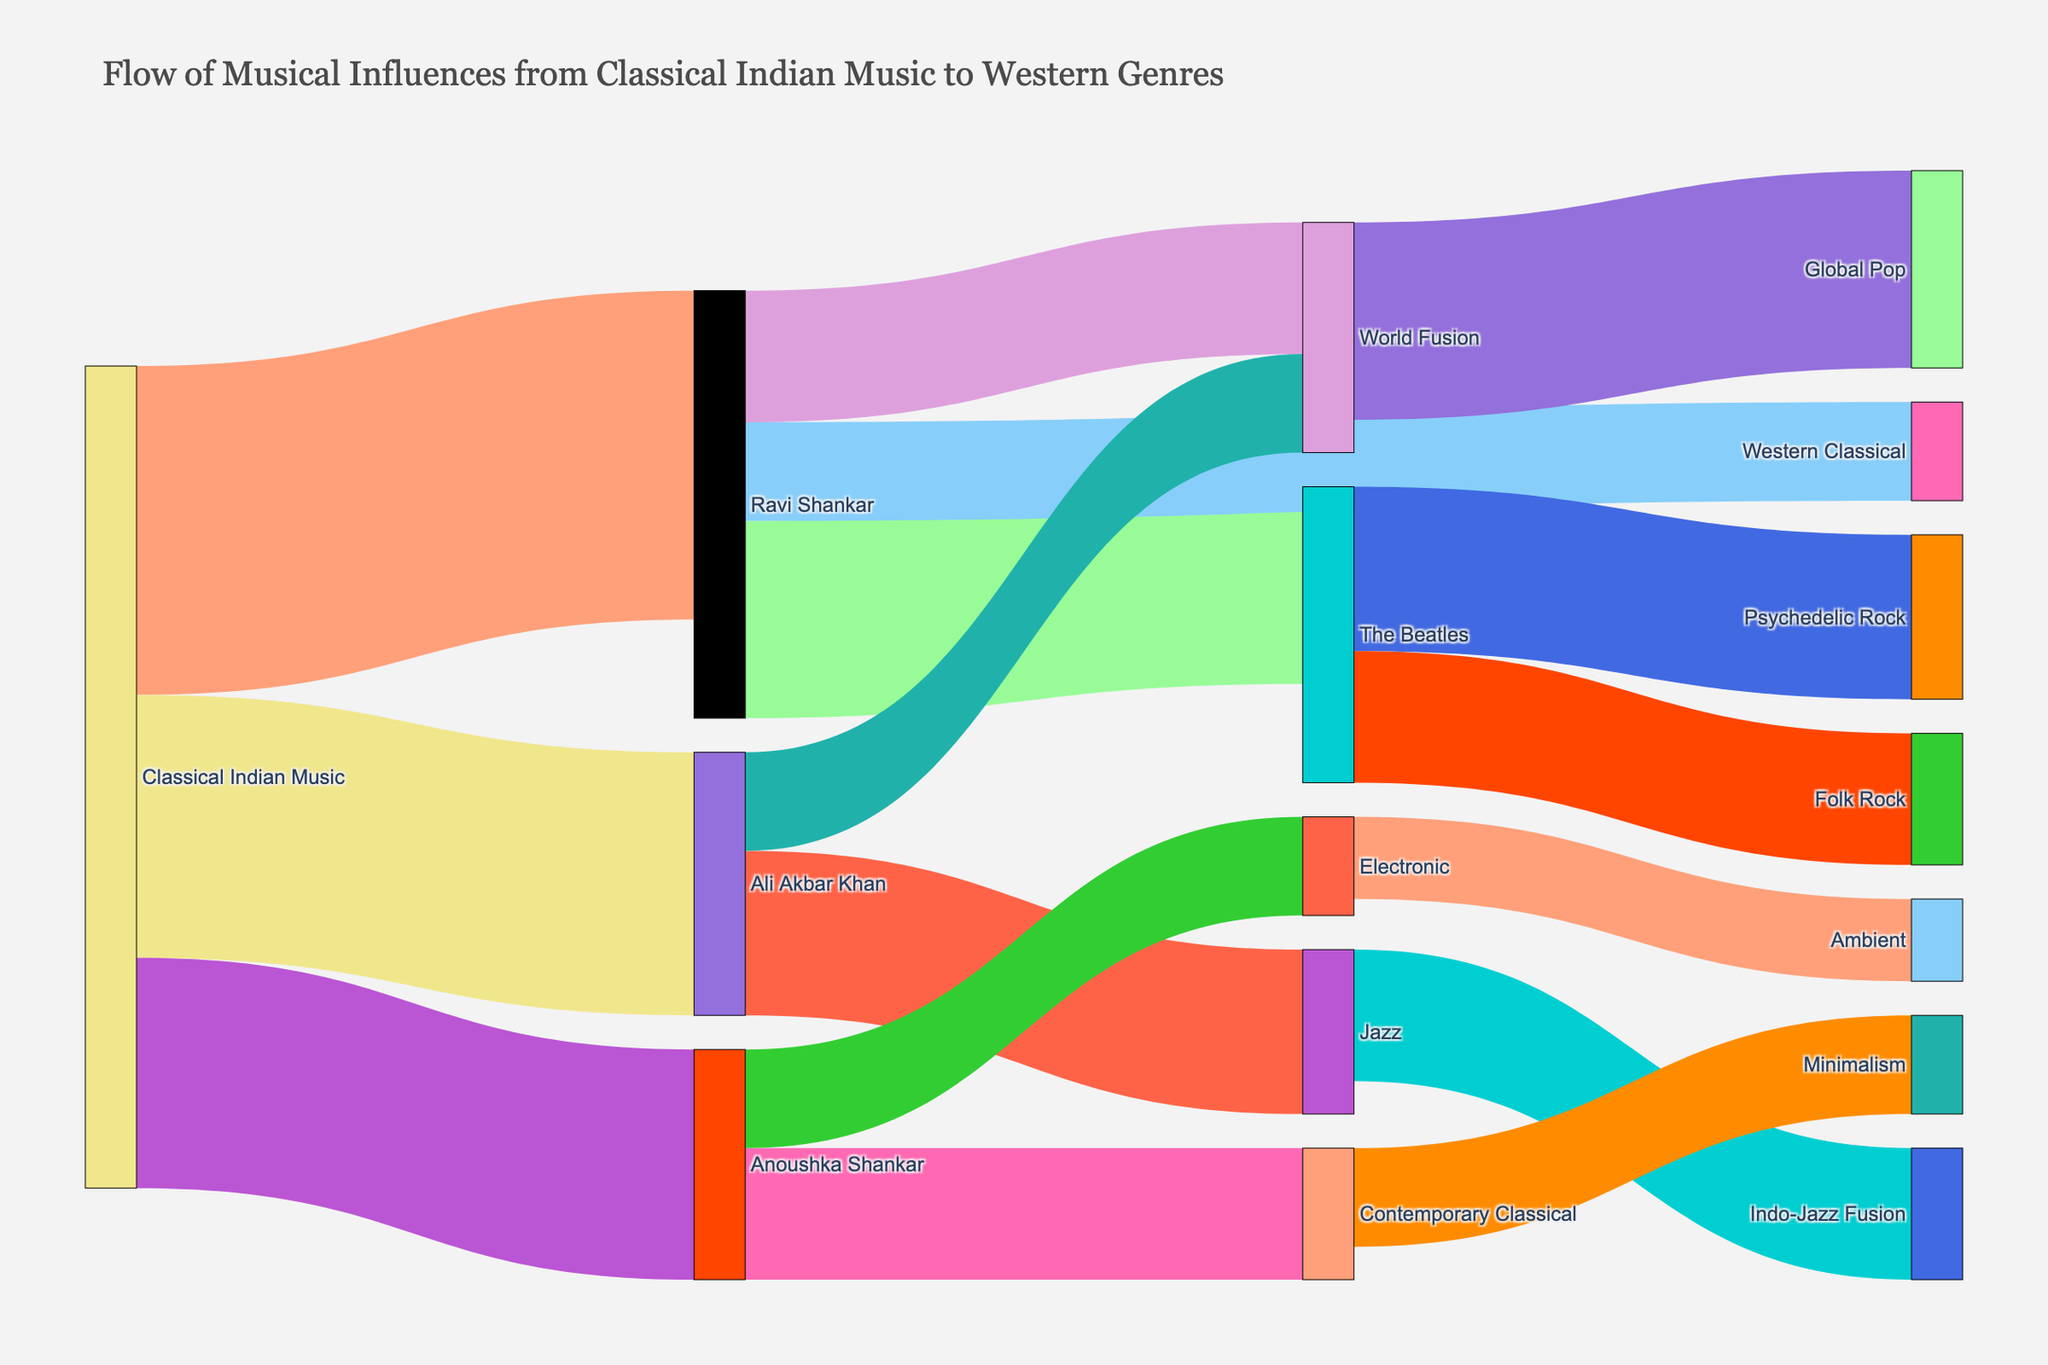What is the title of the Sankey Diagram? The title is prominently displayed at the top of the diagram. It reads "Flow of Musical Influences from Classical Indian Music to Western Genres".
Answer: Flow of Musical Influences from Classical Indian Music to Western Genres How many sources are labeled directly from Classical Indian Music? By checking the labels that directly stem from Classical Indian Music, you can count three: Ravi Shankar, Ali Akbar Khan, and Anoushka Shankar.
Answer: Three Which artist has the greatest influence on World Fusion? To determine this, look at the width of the links that connect to World Fusion. There are two: Ravi Shankar (40) and Ali Akbar Khan (30). Ravi Shankar has the greater influence.
Answer: Ravi Shankar What is the combined influence of Anoushka Shankar on Contemporary Classical and Electronic genres? Look at the values for the links going from Anoushka Shankar to Contemporary Classical (40) and to Electronic (30). Summing these up gives 40 + 30.
Answer: 70 Compare the influences of The Beatles on Psychedelic Rock and Folk Rock. Which genre has more influence, and by how much? The values are 50 for Psychedelic Rock and 40 for Folk Rock. Subtract 40 from 50 to find that Psychedelic Rock has 10 more influence points than Folk Rock.
Answer: Psychedelic Rock by 10 Which genre has the highest value in the World Fusion node? From the diagram, World Fusion receives influence from Ravi Shankar (40), Ali Akbar Khan (30), and passes influence to Global Pop (60). Global Pop has the highest value of 60.
Answer: Global Pop Identify the genre influenced by both The Beatles and Jazz. Observe the Sankey Diagram and notice that there is one genre at the intersection of both The Beatles and Jazz influences: Indo-Jazz Fusion is influenced by Jazz. The Beatles' branches, Folk Rock, and Psychedelic Rock do not intersect with Jazz.
Answer: Indo-Jazz Fusion Which genre connected to Ali Akbar Khan has an influence value of 50? Find the links from Ali Akbar Khan. One leads to Jazz with an influence value of 50.
Answer: Jazz Summarize the nodes influenced by Classical Indian Music through Ravi Shankar, Ali Akbar Khan, and Anoushka Shankar. Ravi Shankar influences The Beatles, Western Classical, and World Fusion. Ali Akbar Khan influences Jazz and World Fusion. Anoushka Shankar influences Contemporary Classical and Electronic.
Answer: The Beatles, Western Classical, World Fusion, Jazz, Contemporary Classical, Electronic Determine the genre with the smallest influence value among all the final genres in the diagram. From the final genres listed, Ambient has the smallest value of 25.
Answer: Ambient 